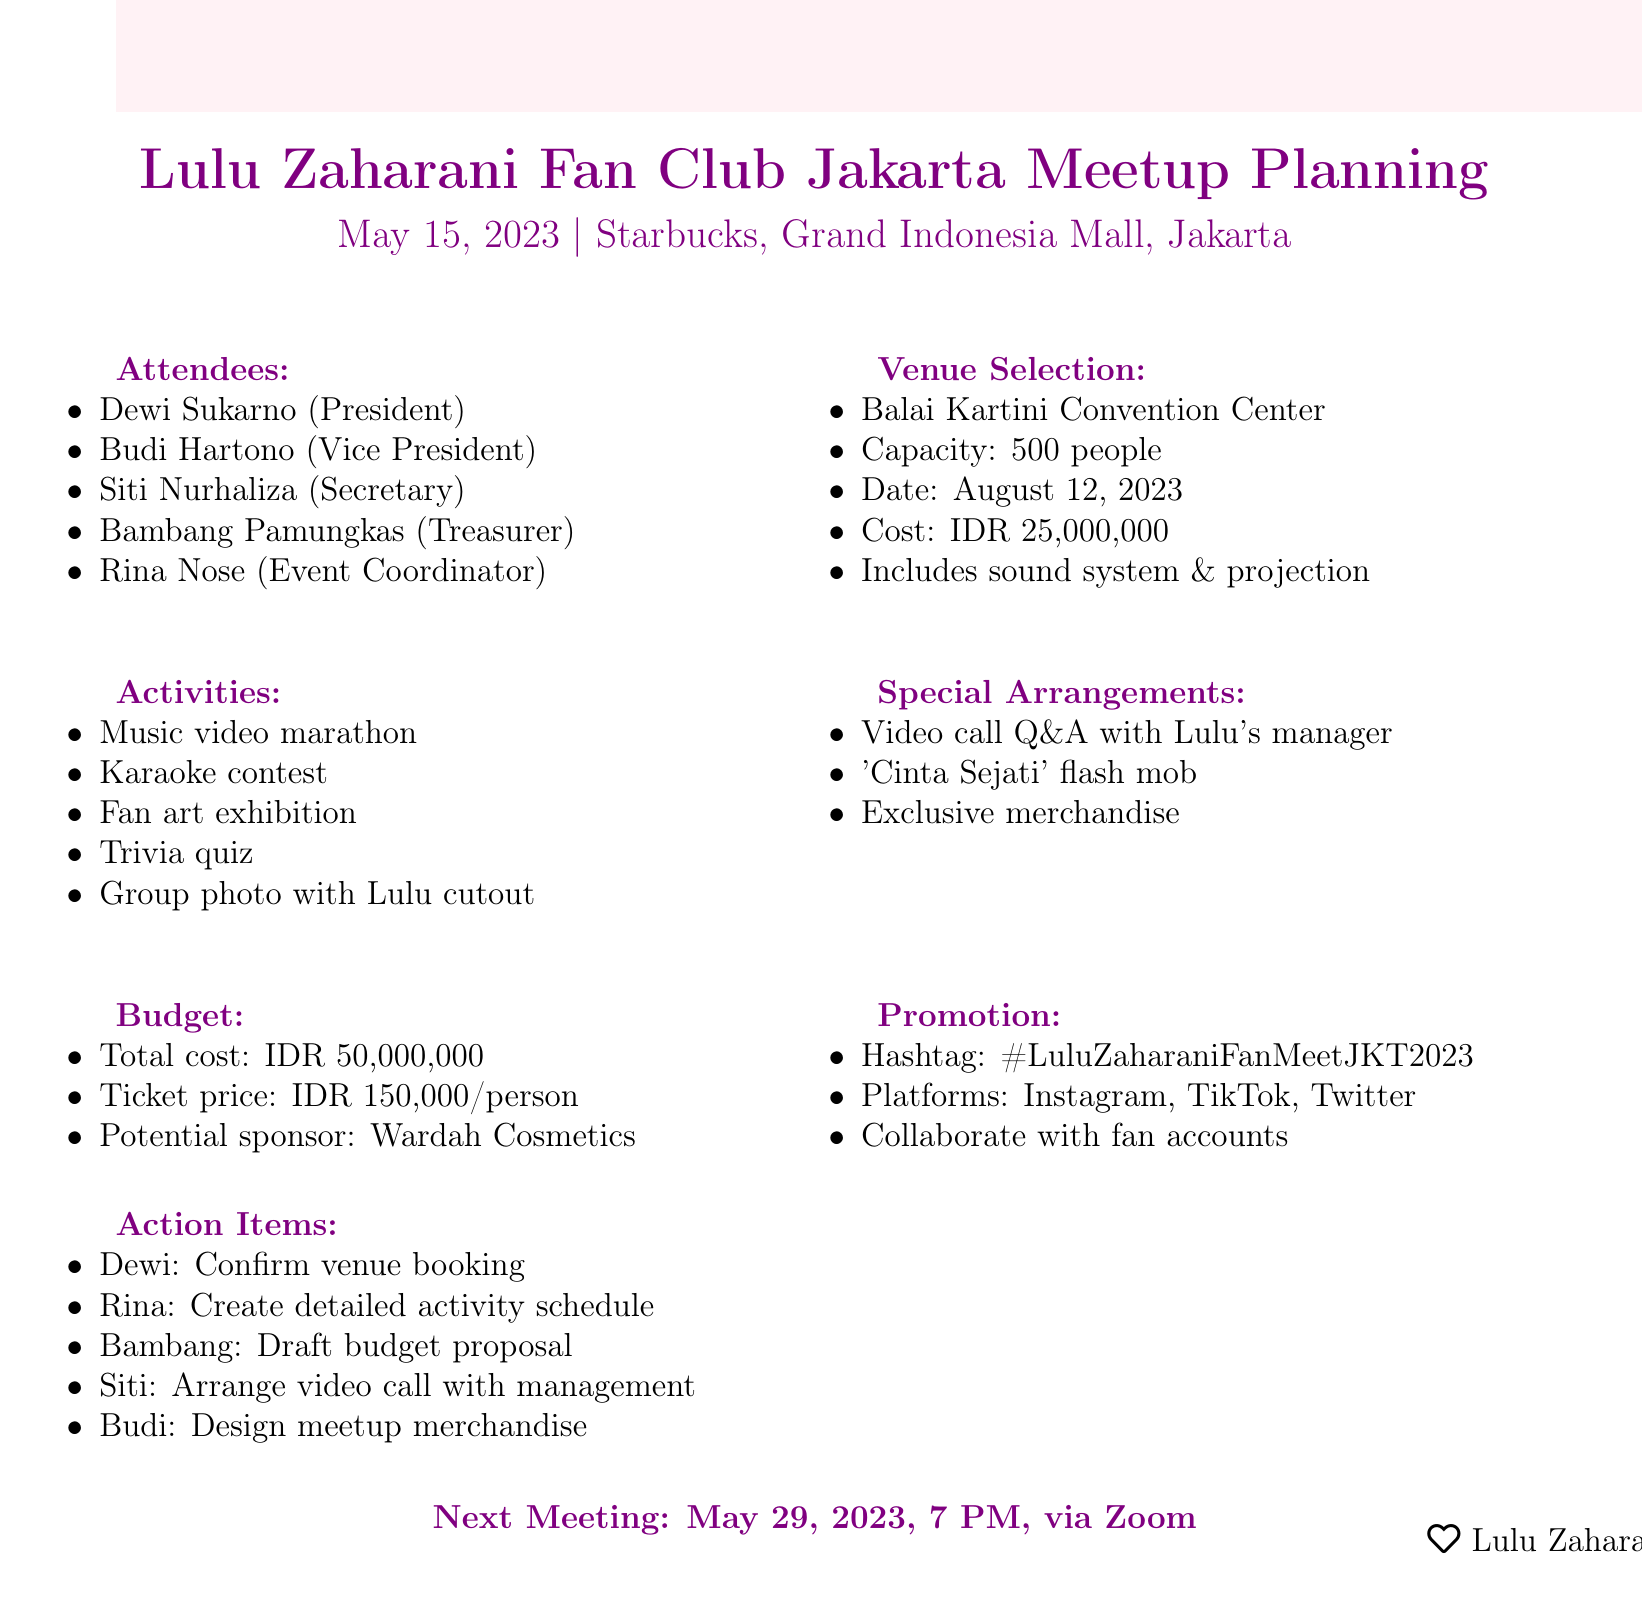what is the meeting date? The meeting date is specified at the beginning of the document as May 15, 2023.
Answer: May 15, 2023 where is the venue for the meetup? The venue for the meetup is indicated in the document under venue selection, which shows Starbucks, Grand Indonesia Mall, Jakarta.
Answer: Starbucks, Grand Indonesia Mall, Jakarta who is the event coordinator? The event coordinator is listed among the attendees, which identifies Rina Nose as that person.
Answer: Rina Nose what is the capacity of the proposed venue? The capacity of the proposed venue is given in the venue selection, stating it can hold 500 people.
Answer: 500 people what is the ticket price suggestion? The ticket price suggestion is noted under budget considerations as IDR 150,000 per person.
Answer: IDR 150,000 per person how many activities are planned for the meetup? The activities planning section enumerates five specific activities planned for the meetup.
Answer: Five what is the total estimated cost for the meetup? The total estimated cost is found in budget considerations, which gives IDR 50,000,000.
Answer: IDR 50,000,000 which brand is a potential sponsor for the event? The document mentions Wardah Cosmetics as a potential sponsor in the budget section.
Answer: Wardah Cosmetics what is the agenda item listed after activities planning? The agenda item following activities planning is the special arrangements section.
Answer: Special Arrangements 